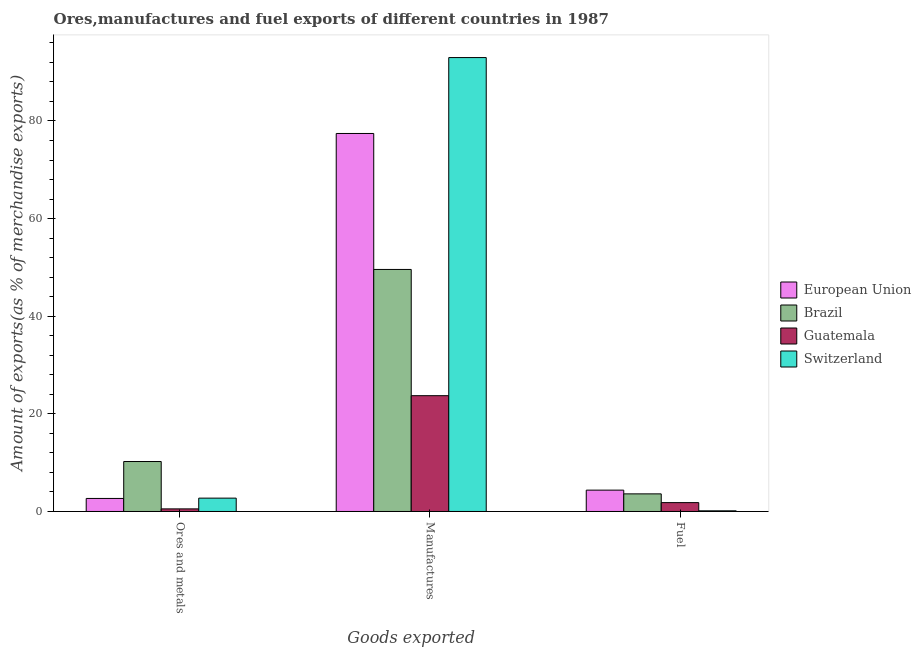How many different coloured bars are there?
Provide a succinct answer. 4. How many groups of bars are there?
Ensure brevity in your answer.  3. How many bars are there on the 3rd tick from the left?
Offer a very short reply. 4. What is the label of the 1st group of bars from the left?
Provide a short and direct response. Ores and metals. What is the percentage of fuel exports in Switzerland?
Give a very brief answer. 0.13. Across all countries, what is the maximum percentage of manufactures exports?
Your answer should be very brief. 92.99. Across all countries, what is the minimum percentage of fuel exports?
Provide a short and direct response. 0.13. In which country was the percentage of ores and metals exports maximum?
Give a very brief answer. Brazil. In which country was the percentage of manufactures exports minimum?
Offer a very short reply. Guatemala. What is the total percentage of fuel exports in the graph?
Offer a very short reply. 9.94. What is the difference between the percentage of manufactures exports in Brazil and that in Switzerland?
Give a very brief answer. -43.41. What is the difference between the percentage of fuel exports in Guatemala and the percentage of manufactures exports in Switzerland?
Provide a succinct answer. -91.17. What is the average percentage of ores and metals exports per country?
Provide a succinct answer. 4.04. What is the difference between the percentage of ores and metals exports and percentage of fuel exports in Brazil?
Make the answer very short. 6.63. What is the ratio of the percentage of fuel exports in Switzerland to that in Guatemala?
Your response must be concise. 0.07. What is the difference between the highest and the second highest percentage of fuel exports?
Provide a succinct answer. 0.77. What is the difference between the highest and the lowest percentage of ores and metals exports?
Provide a short and direct response. 9.7. In how many countries, is the percentage of manufactures exports greater than the average percentage of manufactures exports taken over all countries?
Offer a terse response. 2. What does the 3rd bar from the left in Manufactures represents?
Provide a short and direct response. Guatemala. Is it the case that in every country, the sum of the percentage of ores and metals exports and percentage of manufactures exports is greater than the percentage of fuel exports?
Offer a terse response. Yes. Are all the bars in the graph horizontal?
Keep it short and to the point. No. Are the values on the major ticks of Y-axis written in scientific E-notation?
Offer a very short reply. No. Does the graph contain any zero values?
Keep it short and to the point. No. Does the graph contain grids?
Keep it short and to the point. No. Where does the legend appear in the graph?
Provide a short and direct response. Center right. How are the legend labels stacked?
Make the answer very short. Vertical. What is the title of the graph?
Provide a succinct answer. Ores,manufactures and fuel exports of different countries in 1987. What is the label or title of the X-axis?
Provide a short and direct response. Goods exported. What is the label or title of the Y-axis?
Give a very brief answer. Amount of exports(as % of merchandise exports). What is the Amount of exports(as % of merchandise exports) of European Union in Ores and metals?
Offer a terse response. 2.67. What is the Amount of exports(as % of merchandise exports) in Brazil in Ores and metals?
Give a very brief answer. 10.23. What is the Amount of exports(as % of merchandise exports) of Guatemala in Ores and metals?
Offer a terse response. 0.53. What is the Amount of exports(as % of merchandise exports) of Switzerland in Ores and metals?
Ensure brevity in your answer.  2.73. What is the Amount of exports(as % of merchandise exports) in European Union in Manufactures?
Give a very brief answer. 77.44. What is the Amount of exports(as % of merchandise exports) in Brazil in Manufactures?
Ensure brevity in your answer.  49.59. What is the Amount of exports(as % of merchandise exports) of Guatemala in Manufactures?
Your response must be concise. 23.72. What is the Amount of exports(as % of merchandise exports) of Switzerland in Manufactures?
Keep it short and to the point. 92.99. What is the Amount of exports(as % of merchandise exports) of European Union in Fuel?
Your response must be concise. 4.38. What is the Amount of exports(as % of merchandise exports) of Brazil in Fuel?
Make the answer very short. 3.61. What is the Amount of exports(as % of merchandise exports) in Guatemala in Fuel?
Your answer should be compact. 1.82. What is the Amount of exports(as % of merchandise exports) of Switzerland in Fuel?
Offer a terse response. 0.13. Across all Goods exported, what is the maximum Amount of exports(as % of merchandise exports) of European Union?
Offer a terse response. 77.44. Across all Goods exported, what is the maximum Amount of exports(as % of merchandise exports) in Brazil?
Give a very brief answer. 49.59. Across all Goods exported, what is the maximum Amount of exports(as % of merchandise exports) in Guatemala?
Provide a short and direct response. 23.72. Across all Goods exported, what is the maximum Amount of exports(as % of merchandise exports) of Switzerland?
Provide a short and direct response. 92.99. Across all Goods exported, what is the minimum Amount of exports(as % of merchandise exports) of European Union?
Make the answer very short. 2.67. Across all Goods exported, what is the minimum Amount of exports(as % of merchandise exports) in Brazil?
Offer a terse response. 3.61. Across all Goods exported, what is the minimum Amount of exports(as % of merchandise exports) of Guatemala?
Make the answer very short. 0.53. Across all Goods exported, what is the minimum Amount of exports(as % of merchandise exports) of Switzerland?
Make the answer very short. 0.13. What is the total Amount of exports(as % of merchandise exports) of European Union in the graph?
Offer a very short reply. 84.49. What is the total Amount of exports(as % of merchandise exports) in Brazil in the graph?
Provide a short and direct response. 63.43. What is the total Amount of exports(as % of merchandise exports) in Guatemala in the graph?
Ensure brevity in your answer.  26.07. What is the total Amount of exports(as % of merchandise exports) of Switzerland in the graph?
Provide a succinct answer. 95.86. What is the difference between the Amount of exports(as % of merchandise exports) of European Union in Ores and metals and that in Manufactures?
Offer a terse response. -74.77. What is the difference between the Amount of exports(as % of merchandise exports) of Brazil in Ores and metals and that in Manufactures?
Give a very brief answer. -39.35. What is the difference between the Amount of exports(as % of merchandise exports) of Guatemala in Ores and metals and that in Manufactures?
Make the answer very short. -23.19. What is the difference between the Amount of exports(as % of merchandise exports) of Switzerland in Ores and metals and that in Manufactures?
Keep it short and to the point. -90.26. What is the difference between the Amount of exports(as % of merchandise exports) in European Union in Ores and metals and that in Fuel?
Your answer should be very brief. -1.71. What is the difference between the Amount of exports(as % of merchandise exports) of Brazil in Ores and metals and that in Fuel?
Offer a terse response. 6.63. What is the difference between the Amount of exports(as % of merchandise exports) of Guatemala in Ores and metals and that in Fuel?
Offer a terse response. -1.28. What is the difference between the Amount of exports(as % of merchandise exports) in Switzerland in Ores and metals and that in Fuel?
Your answer should be compact. 2.6. What is the difference between the Amount of exports(as % of merchandise exports) in European Union in Manufactures and that in Fuel?
Ensure brevity in your answer.  73.07. What is the difference between the Amount of exports(as % of merchandise exports) of Brazil in Manufactures and that in Fuel?
Make the answer very short. 45.98. What is the difference between the Amount of exports(as % of merchandise exports) of Guatemala in Manufactures and that in Fuel?
Your answer should be very brief. 21.91. What is the difference between the Amount of exports(as % of merchandise exports) in Switzerland in Manufactures and that in Fuel?
Keep it short and to the point. 92.86. What is the difference between the Amount of exports(as % of merchandise exports) of European Union in Ores and metals and the Amount of exports(as % of merchandise exports) of Brazil in Manufactures?
Provide a succinct answer. -46.92. What is the difference between the Amount of exports(as % of merchandise exports) in European Union in Ores and metals and the Amount of exports(as % of merchandise exports) in Guatemala in Manufactures?
Offer a terse response. -21.05. What is the difference between the Amount of exports(as % of merchandise exports) of European Union in Ores and metals and the Amount of exports(as % of merchandise exports) of Switzerland in Manufactures?
Give a very brief answer. -90.32. What is the difference between the Amount of exports(as % of merchandise exports) of Brazil in Ores and metals and the Amount of exports(as % of merchandise exports) of Guatemala in Manufactures?
Offer a very short reply. -13.49. What is the difference between the Amount of exports(as % of merchandise exports) in Brazil in Ores and metals and the Amount of exports(as % of merchandise exports) in Switzerland in Manufactures?
Your response must be concise. -82.76. What is the difference between the Amount of exports(as % of merchandise exports) in Guatemala in Ores and metals and the Amount of exports(as % of merchandise exports) in Switzerland in Manufactures?
Your answer should be very brief. -92.46. What is the difference between the Amount of exports(as % of merchandise exports) of European Union in Ores and metals and the Amount of exports(as % of merchandise exports) of Brazil in Fuel?
Provide a succinct answer. -0.94. What is the difference between the Amount of exports(as % of merchandise exports) in European Union in Ores and metals and the Amount of exports(as % of merchandise exports) in Guatemala in Fuel?
Give a very brief answer. 0.85. What is the difference between the Amount of exports(as % of merchandise exports) of European Union in Ores and metals and the Amount of exports(as % of merchandise exports) of Switzerland in Fuel?
Make the answer very short. 2.53. What is the difference between the Amount of exports(as % of merchandise exports) in Brazil in Ores and metals and the Amount of exports(as % of merchandise exports) in Guatemala in Fuel?
Offer a terse response. 8.42. What is the difference between the Amount of exports(as % of merchandise exports) of Brazil in Ores and metals and the Amount of exports(as % of merchandise exports) of Switzerland in Fuel?
Provide a succinct answer. 10.1. What is the difference between the Amount of exports(as % of merchandise exports) of Guatemala in Ores and metals and the Amount of exports(as % of merchandise exports) of Switzerland in Fuel?
Offer a terse response. 0.4. What is the difference between the Amount of exports(as % of merchandise exports) in European Union in Manufactures and the Amount of exports(as % of merchandise exports) in Brazil in Fuel?
Your response must be concise. 73.83. What is the difference between the Amount of exports(as % of merchandise exports) of European Union in Manufactures and the Amount of exports(as % of merchandise exports) of Guatemala in Fuel?
Keep it short and to the point. 75.62. What is the difference between the Amount of exports(as % of merchandise exports) of European Union in Manufactures and the Amount of exports(as % of merchandise exports) of Switzerland in Fuel?
Offer a terse response. 77.31. What is the difference between the Amount of exports(as % of merchandise exports) of Brazil in Manufactures and the Amount of exports(as % of merchandise exports) of Guatemala in Fuel?
Give a very brief answer. 47.77. What is the difference between the Amount of exports(as % of merchandise exports) in Brazil in Manufactures and the Amount of exports(as % of merchandise exports) in Switzerland in Fuel?
Ensure brevity in your answer.  49.45. What is the difference between the Amount of exports(as % of merchandise exports) in Guatemala in Manufactures and the Amount of exports(as % of merchandise exports) in Switzerland in Fuel?
Provide a short and direct response. 23.59. What is the average Amount of exports(as % of merchandise exports) of European Union per Goods exported?
Ensure brevity in your answer.  28.16. What is the average Amount of exports(as % of merchandise exports) in Brazil per Goods exported?
Offer a terse response. 21.14. What is the average Amount of exports(as % of merchandise exports) of Guatemala per Goods exported?
Ensure brevity in your answer.  8.69. What is the average Amount of exports(as % of merchandise exports) of Switzerland per Goods exported?
Provide a succinct answer. 31.95. What is the difference between the Amount of exports(as % of merchandise exports) in European Union and Amount of exports(as % of merchandise exports) in Brazil in Ores and metals?
Your answer should be compact. -7.56. What is the difference between the Amount of exports(as % of merchandise exports) of European Union and Amount of exports(as % of merchandise exports) of Guatemala in Ores and metals?
Your answer should be compact. 2.14. What is the difference between the Amount of exports(as % of merchandise exports) in European Union and Amount of exports(as % of merchandise exports) in Switzerland in Ores and metals?
Offer a very short reply. -0.06. What is the difference between the Amount of exports(as % of merchandise exports) of Brazil and Amount of exports(as % of merchandise exports) of Guatemala in Ores and metals?
Give a very brief answer. 9.7. What is the difference between the Amount of exports(as % of merchandise exports) in Brazil and Amount of exports(as % of merchandise exports) in Switzerland in Ores and metals?
Offer a terse response. 7.5. What is the difference between the Amount of exports(as % of merchandise exports) in Guatemala and Amount of exports(as % of merchandise exports) in Switzerland in Ores and metals?
Your answer should be very brief. -2.2. What is the difference between the Amount of exports(as % of merchandise exports) in European Union and Amount of exports(as % of merchandise exports) in Brazil in Manufactures?
Your response must be concise. 27.86. What is the difference between the Amount of exports(as % of merchandise exports) in European Union and Amount of exports(as % of merchandise exports) in Guatemala in Manufactures?
Give a very brief answer. 53.72. What is the difference between the Amount of exports(as % of merchandise exports) in European Union and Amount of exports(as % of merchandise exports) in Switzerland in Manufactures?
Your answer should be compact. -15.55. What is the difference between the Amount of exports(as % of merchandise exports) of Brazil and Amount of exports(as % of merchandise exports) of Guatemala in Manufactures?
Provide a succinct answer. 25.86. What is the difference between the Amount of exports(as % of merchandise exports) in Brazil and Amount of exports(as % of merchandise exports) in Switzerland in Manufactures?
Give a very brief answer. -43.41. What is the difference between the Amount of exports(as % of merchandise exports) of Guatemala and Amount of exports(as % of merchandise exports) of Switzerland in Manufactures?
Your answer should be compact. -69.27. What is the difference between the Amount of exports(as % of merchandise exports) in European Union and Amount of exports(as % of merchandise exports) in Brazil in Fuel?
Your response must be concise. 0.77. What is the difference between the Amount of exports(as % of merchandise exports) of European Union and Amount of exports(as % of merchandise exports) of Guatemala in Fuel?
Ensure brevity in your answer.  2.56. What is the difference between the Amount of exports(as % of merchandise exports) in European Union and Amount of exports(as % of merchandise exports) in Switzerland in Fuel?
Give a very brief answer. 4.24. What is the difference between the Amount of exports(as % of merchandise exports) in Brazil and Amount of exports(as % of merchandise exports) in Guatemala in Fuel?
Give a very brief answer. 1.79. What is the difference between the Amount of exports(as % of merchandise exports) of Brazil and Amount of exports(as % of merchandise exports) of Switzerland in Fuel?
Offer a terse response. 3.47. What is the difference between the Amount of exports(as % of merchandise exports) of Guatemala and Amount of exports(as % of merchandise exports) of Switzerland in Fuel?
Make the answer very short. 1.68. What is the ratio of the Amount of exports(as % of merchandise exports) of European Union in Ores and metals to that in Manufactures?
Offer a terse response. 0.03. What is the ratio of the Amount of exports(as % of merchandise exports) of Brazil in Ores and metals to that in Manufactures?
Your answer should be very brief. 0.21. What is the ratio of the Amount of exports(as % of merchandise exports) of Guatemala in Ores and metals to that in Manufactures?
Your answer should be very brief. 0.02. What is the ratio of the Amount of exports(as % of merchandise exports) in Switzerland in Ores and metals to that in Manufactures?
Your answer should be compact. 0.03. What is the ratio of the Amount of exports(as % of merchandise exports) of European Union in Ores and metals to that in Fuel?
Provide a short and direct response. 0.61. What is the ratio of the Amount of exports(as % of merchandise exports) in Brazil in Ores and metals to that in Fuel?
Offer a very short reply. 2.84. What is the ratio of the Amount of exports(as % of merchandise exports) of Guatemala in Ores and metals to that in Fuel?
Make the answer very short. 0.29. What is the ratio of the Amount of exports(as % of merchandise exports) of Switzerland in Ores and metals to that in Fuel?
Provide a succinct answer. 20.27. What is the ratio of the Amount of exports(as % of merchandise exports) in European Union in Manufactures to that in Fuel?
Make the answer very short. 17.7. What is the ratio of the Amount of exports(as % of merchandise exports) of Brazil in Manufactures to that in Fuel?
Offer a very short reply. 13.74. What is the ratio of the Amount of exports(as % of merchandise exports) of Guatemala in Manufactures to that in Fuel?
Your response must be concise. 13.05. What is the ratio of the Amount of exports(as % of merchandise exports) of Switzerland in Manufactures to that in Fuel?
Offer a very short reply. 689.22. What is the difference between the highest and the second highest Amount of exports(as % of merchandise exports) in European Union?
Make the answer very short. 73.07. What is the difference between the highest and the second highest Amount of exports(as % of merchandise exports) of Brazil?
Your response must be concise. 39.35. What is the difference between the highest and the second highest Amount of exports(as % of merchandise exports) in Guatemala?
Offer a terse response. 21.91. What is the difference between the highest and the second highest Amount of exports(as % of merchandise exports) of Switzerland?
Offer a terse response. 90.26. What is the difference between the highest and the lowest Amount of exports(as % of merchandise exports) of European Union?
Give a very brief answer. 74.77. What is the difference between the highest and the lowest Amount of exports(as % of merchandise exports) in Brazil?
Provide a short and direct response. 45.98. What is the difference between the highest and the lowest Amount of exports(as % of merchandise exports) of Guatemala?
Provide a short and direct response. 23.19. What is the difference between the highest and the lowest Amount of exports(as % of merchandise exports) in Switzerland?
Provide a succinct answer. 92.86. 